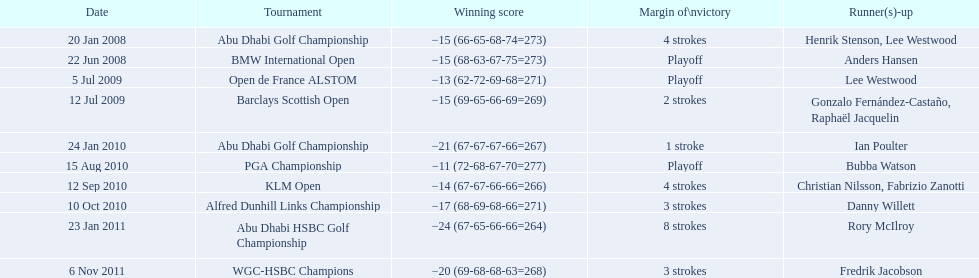Which tournaments did martin kaymer participate in? Abu Dhabi Golf Championship, BMW International Open, Open de France ALSTOM, Barclays Scottish Open, Abu Dhabi Golf Championship, PGA Championship, KLM Open, Alfred Dunhill Links Championship, Abu Dhabi HSBC Golf Championship, WGC-HSBC Champions. How many of these tournaments were won through a playoff? BMW International Open, Open de France ALSTOM, PGA Championship. Which of those tournaments took place in 2010? PGA Championship. Who had to top score next to martin kaymer for that tournament? Bubba Watson. 